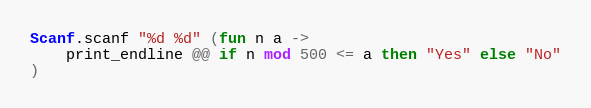Convert code to text. <code><loc_0><loc_0><loc_500><loc_500><_OCaml_>Scanf.scanf "%d %d" (fun n a ->
    print_endline @@ if n mod 500 <= a then "Yes" else "No"
)</code> 